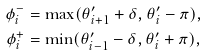<formula> <loc_0><loc_0><loc_500><loc_500>\phi ^ { - } _ { i } & = \max ( \theta ^ { \prime } _ { i + 1 } + \delta , \theta ^ { \prime } _ { i } - \pi ) , \\ \phi ^ { + } _ { i } & = \min ( \theta ^ { \prime } _ { i - 1 } - \delta , \theta ^ { \prime } _ { i } + \pi ) ,</formula> 